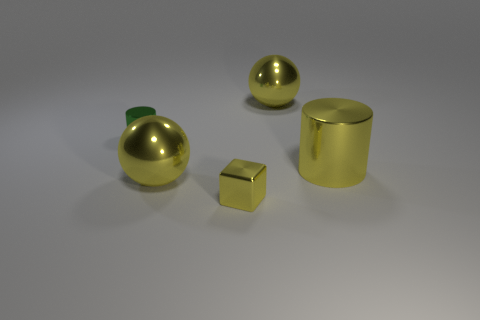Subtract all blue cylinders. Subtract all red balls. How many cylinders are left? 2 Subtract all red cubes. How many cyan balls are left? 0 Add 1 objects. How many greens exist? 0 Subtract all small purple metal things. Subtract all green shiny cylinders. How many objects are left? 4 Add 4 big cylinders. How many big cylinders are left? 5 Add 1 large cylinders. How many large cylinders exist? 2 Add 4 large yellow shiny balls. How many objects exist? 9 Subtract all yellow cylinders. How many cylinders are left? 1 Subtract 0 cyan cubes. How many objects are left? 5 How many yellow balls must be subtracted to get 1 yellow balls? 1 